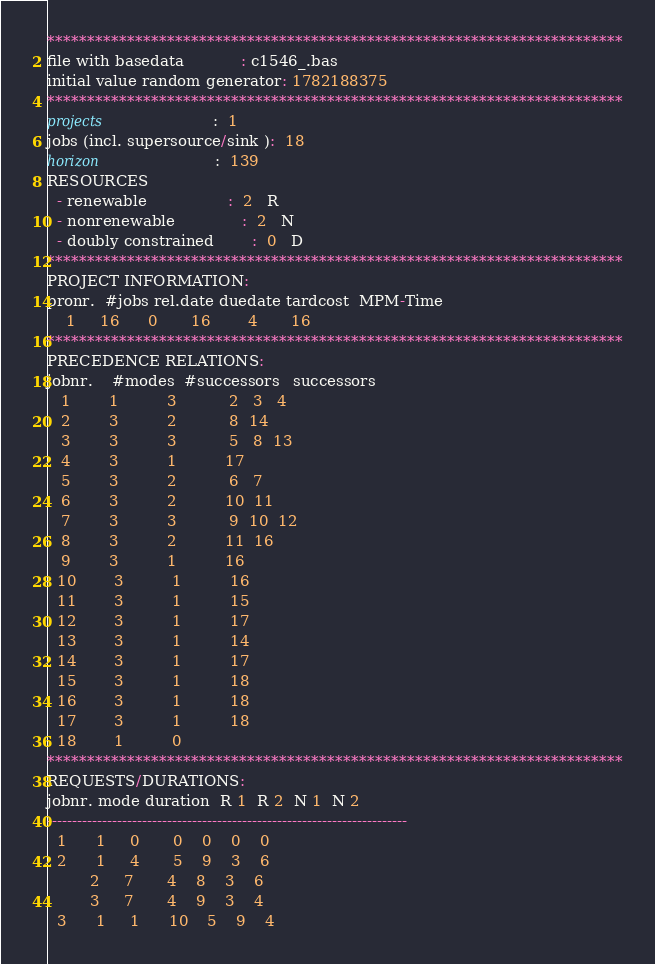Convert code to text. <code><loc_0><loc_0><loc_500><loc_500><_ObjectiveC_>************************************************************************
file with basedata            : c1546_.bas
initial value random generator: 1782188375
************************************************************************
projects                      :  1
jobs (incl. supersource/sink ):  18
horizon                       :  139
RESOURCES
  - renewable                 :  2   R
  - nonrenewable              :  2   N
  - doubly constrained        :  0   D
************************************************************************
PROJECT INFORMATION:
pronr.  #jobs rel.date duedate tardcost  MPM-Time
    1     16      0       16        4       16
************************************************************************
PRECEDENCE RELATIONS:
jobnr.    #modes  #successors   successors
   1        1          3           2   3   4
   2        3          2           8  14
   3        3          3           5   8  13
   4        3          1          17
   5        3          2           6   7
   6        3          2          10  11
   7        3          3           9  10  12
   8        3          2          11  16
   9        3          1          16
  10        3          1          16
  11        3          1          15
  12        3          1          17
  13        3          1          14
  14        3          1          17
  15        3          1          18
  16        3          1          18
  17        3          1          18
  18        1          0        
************************************************************************
REQUESTS/DURATIONS:
jobnr. mode duration  R 1  R 2  N 1  N 2
------------------------------------------------------------------------
  1      1     0       0    0    0    0
  2      1     4       5    9    3    6
         2     7       4    8    3    6
         3     7       4    9    3    4
  3      1     1      10    5    9    4</code> 